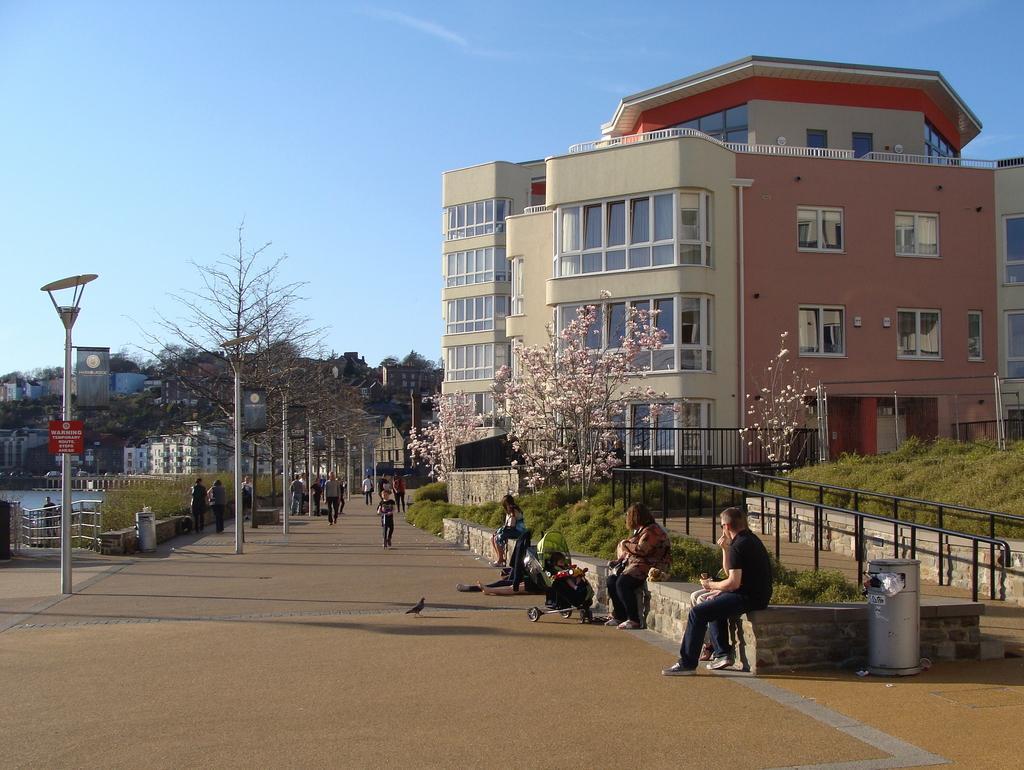Can you describe this image briefly? In this picture we can see some people are standing and some people are sitting, on the left side there is a pole, a board and water, on the right side there is grass, we can see some trees in the middle, in the background there are some buildings, there is a dustbin at the right bottom, we can see the sky at the top of the picture. 